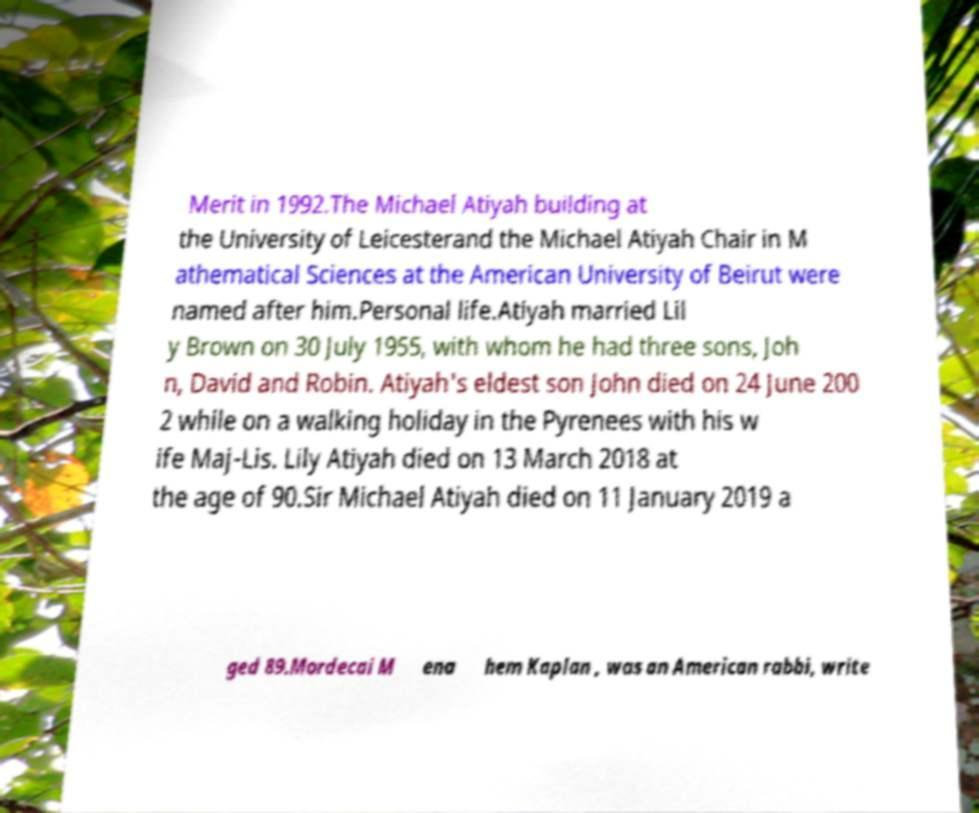Can you accurately transcribe the text from the provided image for me? Merit in 1992.The Michael Atiyah building at the University of Leicesterand the Michael Atiyah Chair in M athematical Sciences at the American University of Beirut were named after him.Personal life.Atiyah married Lil y Brown on 30 July 1955, with whom he had three sons, Joh n, David and Robin. Atiyah's eldest son John died on 24 June 200 2 while on a walking holiday in the Pyrenees with his w ife Maj-Lis. Lily Atiyah died on 13 March 2018 at the age of 90.Sir Michael Atiyah died on 11 January 2019 a ged 89.Mordecai M ena hem Kaplan , was an American rabbi, write 